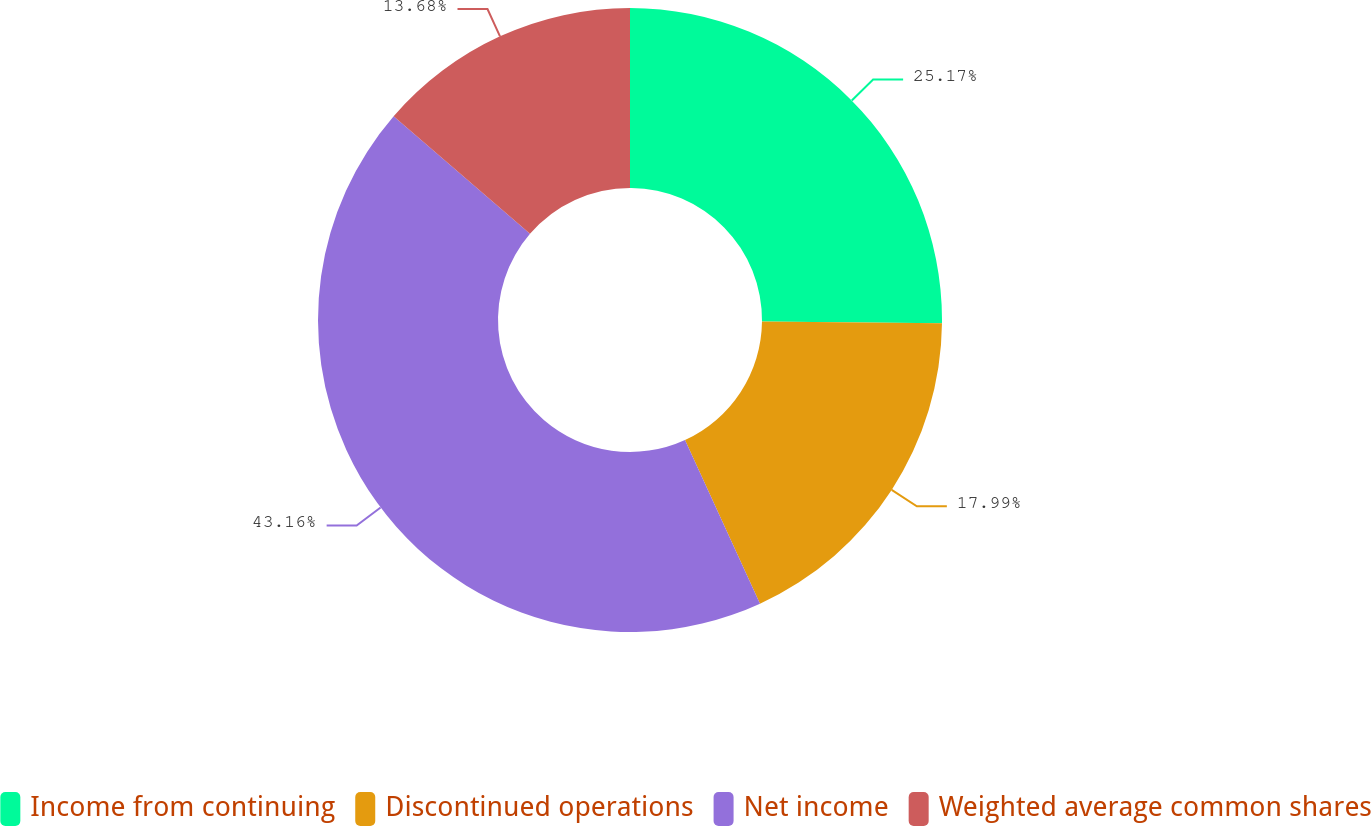Convert chart to OTSL. <chart><loc_0><loc_0><loc_500><loc_500><pie_chart><fcel>Income from continuing<fcel>Discontinued operations<fcel>Net income<fcel>Weighted average common shares<nl><fcel>25.17%<fcel>17.99%<fcel>43.16%<fcel>13.68%<nl></chart> 